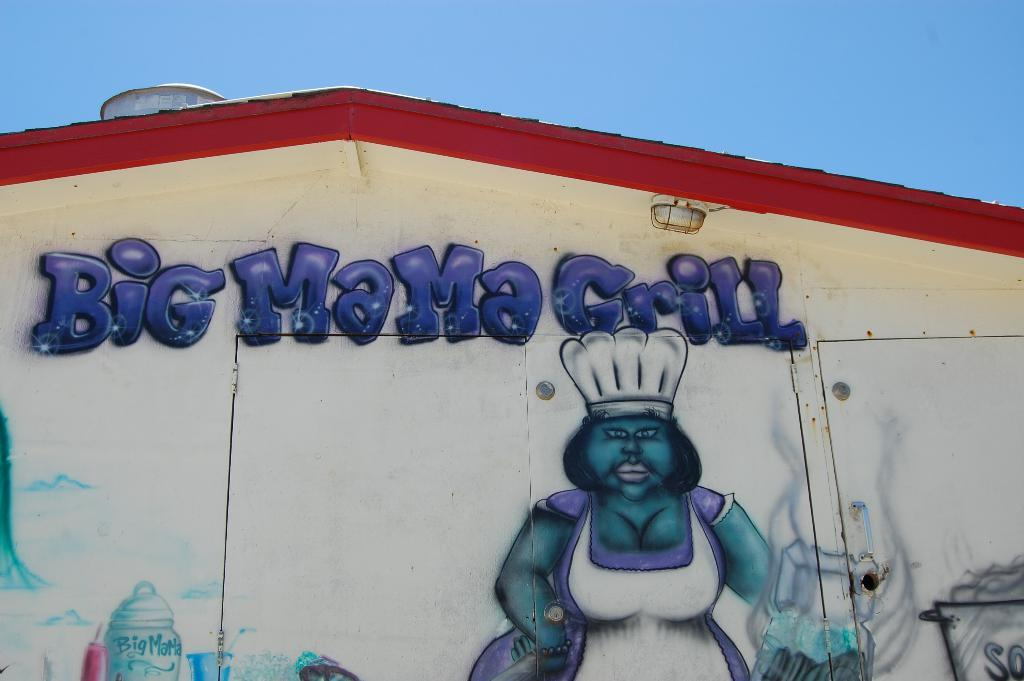What can be seen on the wall in the image? There is a drawing on the wall in the image. What is featured on the drawing? There is text written on the drawing. What advice is given by the cannon in the image? There is no cannon present in the image, and therefore no advice can be given by it. 